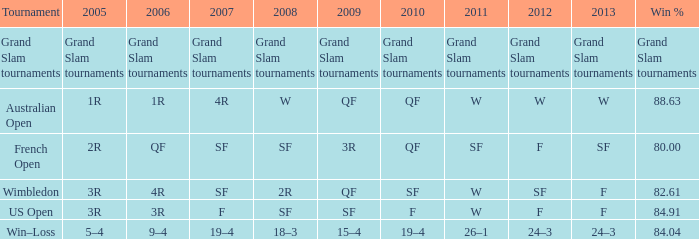What from 2007 has a science fiction connection in 2008 and a fantasy connection in 2010? F. 